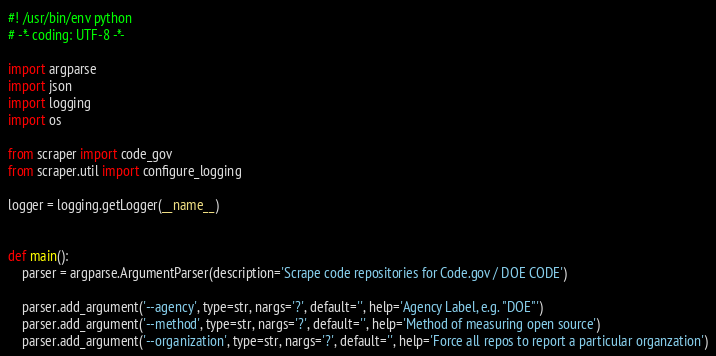Convert code to text. <code><loc_0><loc_0><loc_500><loc_500><_Python_>#! /usr/bin/env python
# -*- coding: UTF-8 -*-

import argparse
import json
import logging
import os

from scraper import code_gov
from scraper.util import configure_logging

logger = logging.getLogger(__name__)


def main():
    parser = argparse.ArgumentParser(description='Scrape code repositories for Code.gov / DOE CODE')

    parser.add_argument('--agency', type=str, nargs='?', default='', help='Agency Label, e.g. "DOE"')
    parser.add_argument('--method', type=str, nargs='?', default='', help='Method of measuring open source')
    parser.add_argument('--organization', type=str, nargs='?', default='', help='Force all repos to report a particular organzation')</code> 